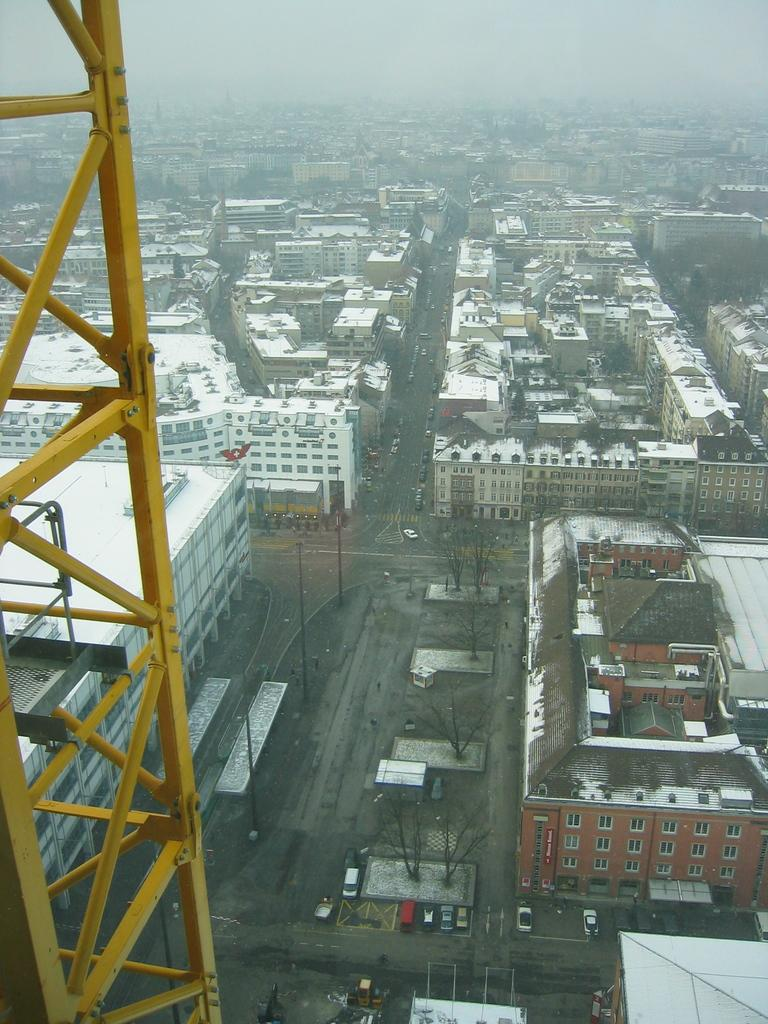What is the main structure in the image? There is a tower in the image. What other types of structures can be seen in the image? There are buildings in the image. What objects are present that are used for support or signaling? There are poles in the image. What type of natural elements are visible in the image? There are trees in the image. What man-made objects are used for transportation in the image? There are vehicles in the image. What is the color of the sky in the background of the image? The sky in the background appears to be white. How many mice are hiding behind the tower in the image? There are no mice present in the image. What type of mailbox can be seen near the vehicles in the image? There is no mailbox present in the image. 